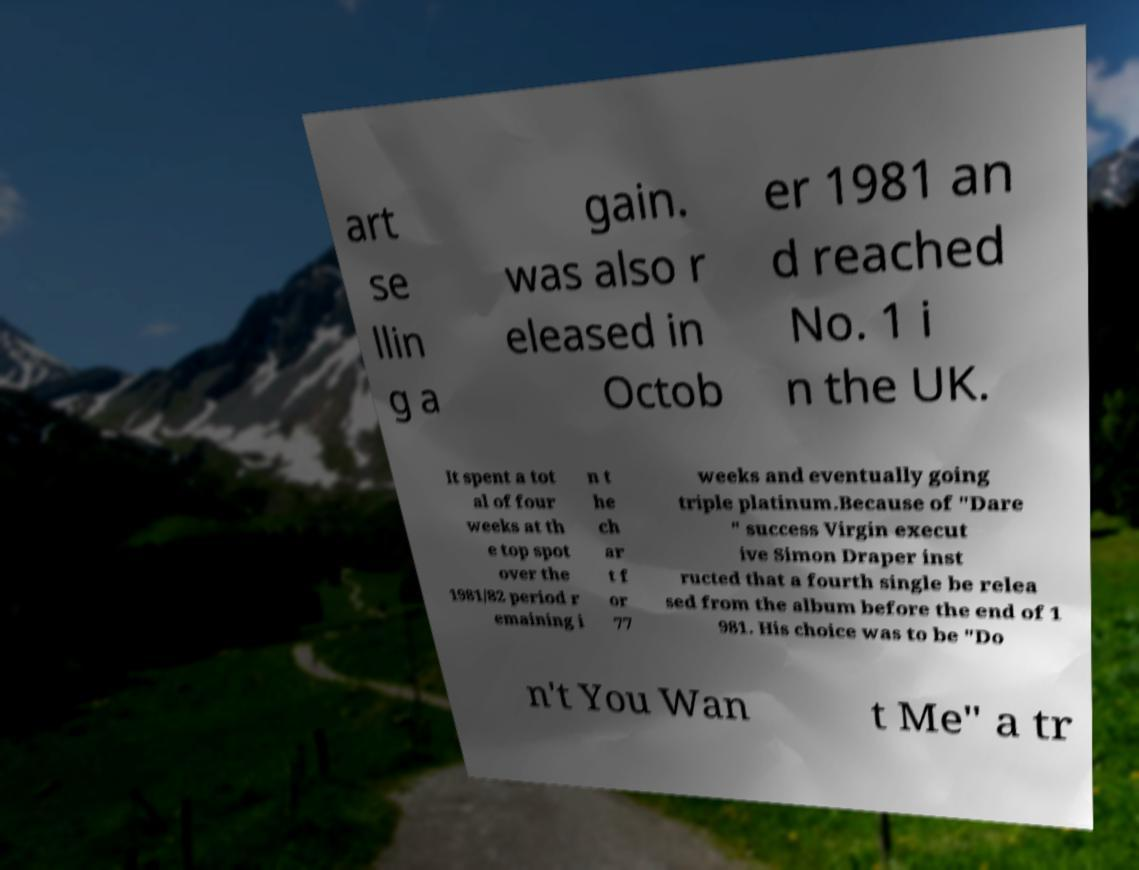Please identify and transcribe the text found in this image. art se llin g a gain. was also r eleased in Octob er 1981 an d reached No. 1 i n the UK. It spent a tot al of four weeks at th e top spot over the 1981/82 period r emaining i n t he ch ar t f or 77 weeks and eventually going triple platinum.Because of "Dare " success Virgin execut ive Simon Draper inst ructed that a fourth single be relea sed from the album before the end of 1 981. His choice was to be "Do n't You Wan t Me" a tr 